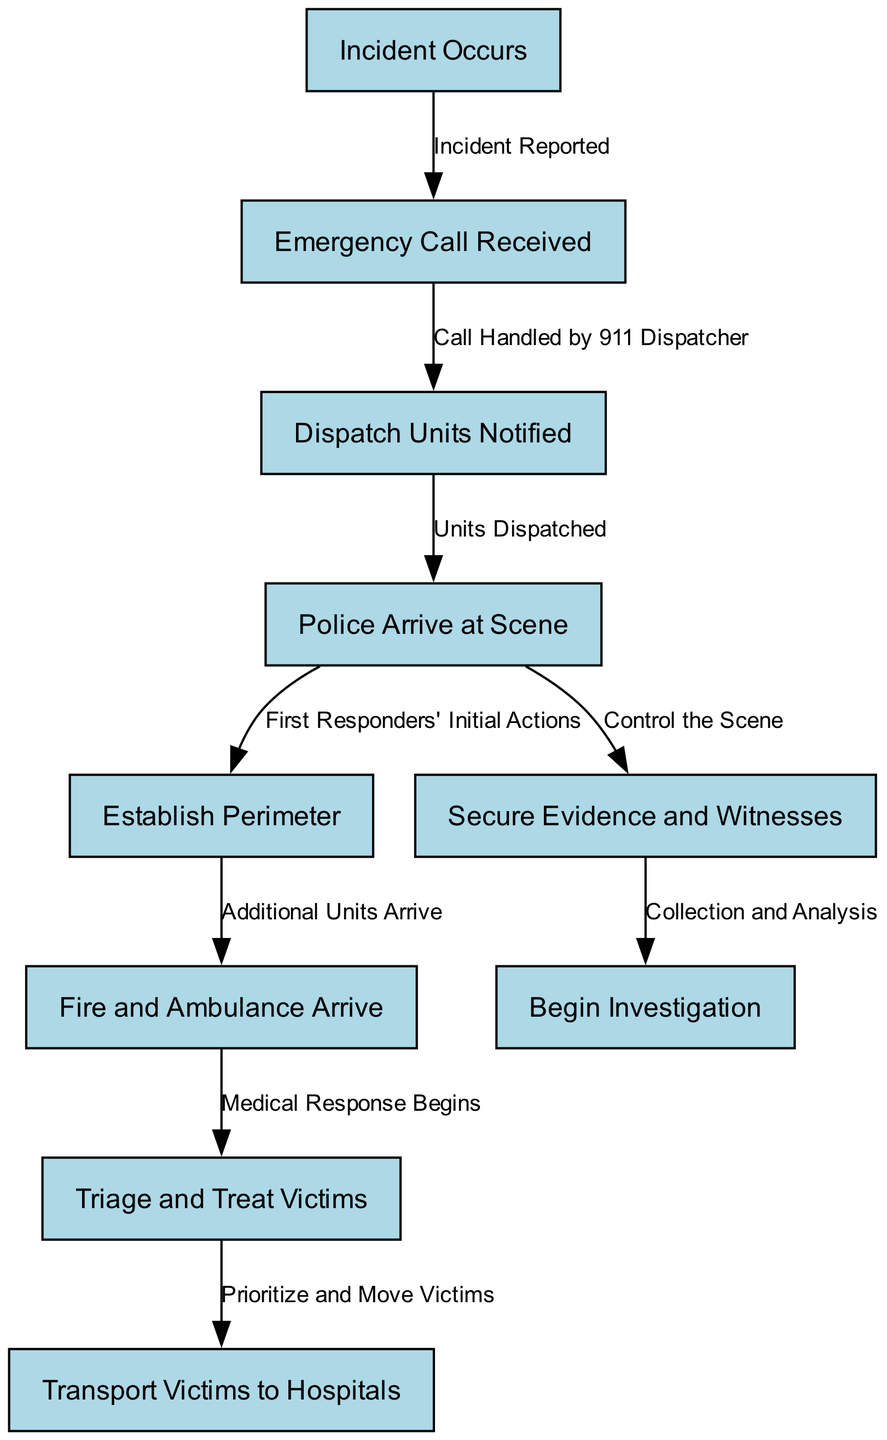What is the first action in the flowchart? The first action is "Incident Occurs," which is represented as the starting node in the diagram.
Answer: Incident Occurs How many total nodes are in the diagram? By counting each unique action or event represented, we identify 10 nodes in total.
Answer: 10 What action follows "Emergency Call Received"? The action that follows "Emergency Call Received" is "Dispatch Units Notified," establishing the next step in response efforts.
Answer: Dispatch Units Notified What is the last step in the response flow? The last step, which indicates the final action taken in the sequence of responses, is "Begin Investigation."
Answer: Begin Investigation Which two actions are taken simultaneously after "Police Arrive at Scene"? The actions taken simultaneously after "Police Arrive at Scene" are "Establish Perimeter" and "Secure Evidence and Witnesses." Both actions occur concurrently.
Answer: Establish Perimeter and Secure Evidence and Witnesses What is the relationship between "Triage and Treat Victims" and "Transport Victims to Hospitals"? The relationship is that "Triage and Treat Victims" directly leads to "Transport Victims to Hospitals," indicating a sequence where treatment precedes transportation.
Answer: Triage and Treat Victims leads to Transport Victims to Hospitals What does the edge labeled "Control the Scene" signify? The edge labeled "Control the Scene" signifies that once the police arrive, one of their immediate priorities is to manage and control the incident scene.
Answer: Manage and control the incident scene How does the "Medical Response Begins" action connect to the rest of the responses? "Medical Response Begins" is crucial as it initiates the treatment of victims following the arrival of fire and ambulance units, marking a shift from initial response to active victim assistance.
Answer: Initiates treatment of victims What indicates evidence collection in the flowchart? The action "Secure Evidence and Witnesses" indicates the measures taken for collecting evidence and interviewing witnesses after securing the scene.
Answer: Secure Evidence and Witnesses 